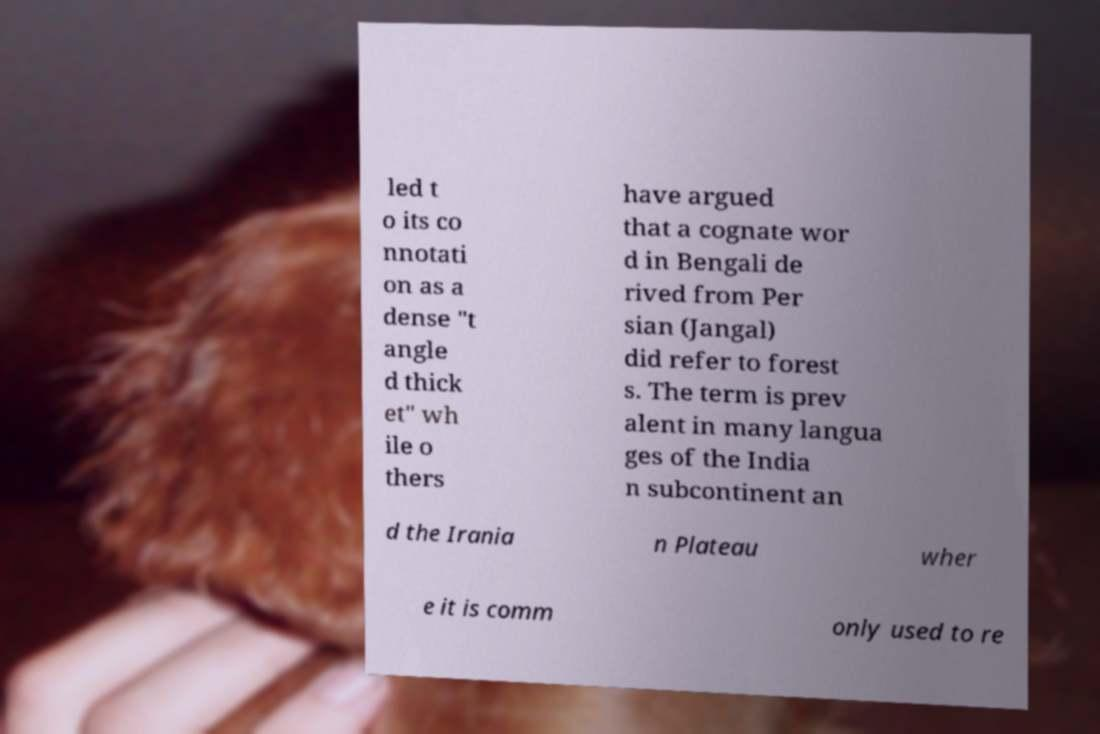Please identify and transcribe the text found in this image. led t o its co nnotati on as a dense "t angle d thick et" wh ile o thers have argued that a cognate wor d in Bengali de rived from Per sian (Jangal) did refer to forest s. The term is prev alent in many langua ges of the India n subcontinent an d the Irania n Plateau wher e it is comm only used to re 